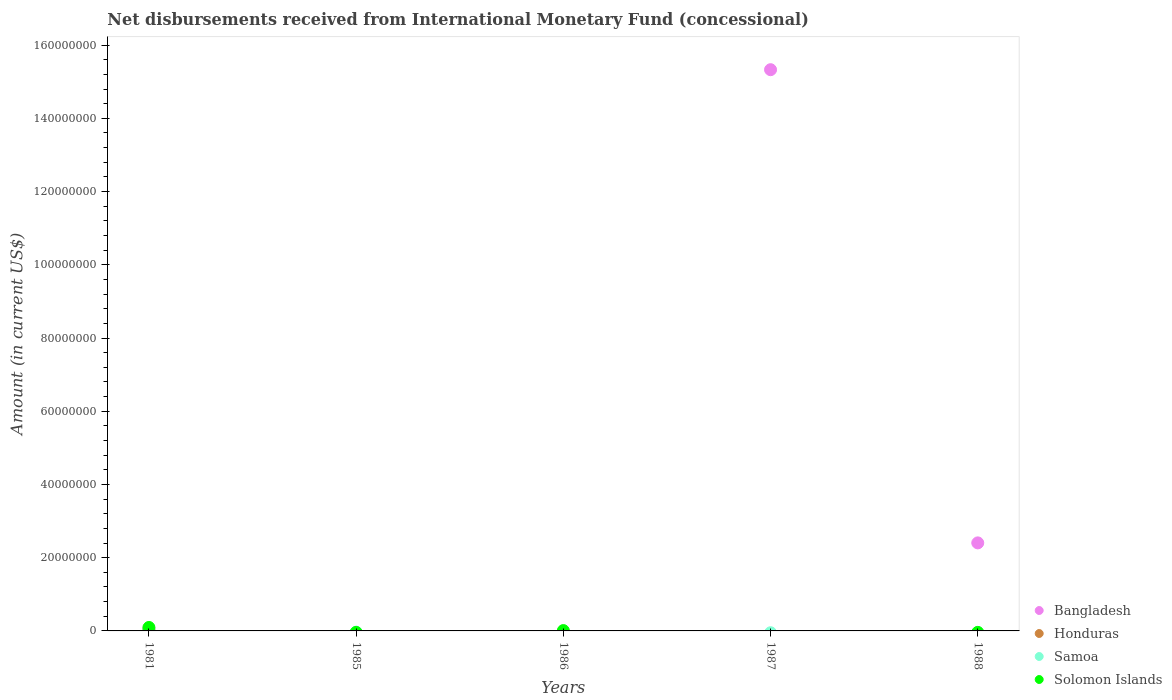Across all years, what is the maximum amount of disbursements received from International Monetary Fund in Solomon Islands?
Provide a succinct answer. 9.44e+05. Across all years, what is the minimum amount of disbursements received from International Monetary Fund in Samoa?
Ensure brevity in your answer.  0. In which year was the amount of disbursements received from International Monetary Fund in Honduras maximum?
Provide a succinct answer. 1981. What is the total amount of disbursements received from International Monetary Fund in Honduras in the graph?
Offer a terse response. 1.11e+05. What is the average amount of disbursements received from International Monetary Fund in Samoa per year?
Your answer should be compact. 1800. In the year 1981, what is the difference between the amount of disbursements received from International Monetary Fund in Solomon Islands and amount of disbursements received from International Monetary Fund in Bangladesh?
Make the answer very short. 3.50e+05. What is the ratio of the amount of disbursements received from International Monetary Fund in Bangladesh in 1987 to that in 1988?
Ensure brevity in your answer.  6.38. What is the difference between the highest and the second highest amount of disbursements received from International Monetary Fund in Bangladesh?
Offer a terse response. 1.29e+08. What is the difference between the highest and the lowest amount of disbursements received from International Monetary Fund in Honduras?
Your answer should be compact. 1.11e+05. Is the amount of disbursements received from International Monetary Fund in Bangladesh strictly greater than the amount of disbursements received from International Monetary Fund in Honduras over the years?
Offer a terse response. No. How many years are there in the graph?
Provide a succinct answer. 5. What is the difference between two consecutive major ticks on the Y-axis?
Make the answer very short. 2.00e+07. Are the values on the major ticks of Y-axis written in scientific E-notation?
Your answer should be very brief. No. Does the graph contain any zero values?
Offer a very short reply. Yes. Does the graph contain grids?
Provide a short and direct response. No. Where does the legend appear in the graph?
Your response must be concise. Bottom right. How many legend labels are there?
Offer a very short reply. 4. How are the legend labels stacked?
Offer a terse response. Vertical. What is the title of the graph?
Offer a very short reply. Net disbursements received from International Monetary Fund (concessional). What is the label or title of the Y-axis?
Your answer should be very brief. Amount (in current US$). What is the Amount (in current US$) of Bangladesh in 1981?
Your answer should be very brief. 5.94e+05. What is the Amount (in current US$) in Honduras in 1981?
Ensure brevity in your answer.  1.11e+05. What is the Amount (in current US$) of Samoa in 1981?
Ensure brevity in your answer.  9000. What is the Amount (in current US$) in Solomon Islands in 1981?
Give a very brief answer. 9.44e+05. What is the Amount (in current US$) of Solomon Islands in 1985?
Make the answer very short. 0. What is the Amount (in current US$) in Bangladesh in 1986?
Provide a short and direct response. 0. What is the Amount (in current US$) of Honduras in 1986?
Offer a very short reply. 0. What is the Amount (in current US$) of Solomon Islands in 1986?
Offer a terse response. 9.10e+04. What is the Amount (in current US$) in Bangladesh in 1987?
Your answer should be compact. 1.53e+08. What is the Amount (in current US$) in Honduras in 1987?
Offer a terse response. 0. What is the Amount (in current US$) in Solomon Islands in 1987?
Give a very brief answer. 0. What is the Amount (in current US$) of Bangladesh in 1988?
Give a very brief answer. 2.40e+07. What is the Amount (in current US$) of Honduras in 1988?
Your response must be concise. 0. What is the Amount (in current US$) of Samoa in 1988?
Make the answer very short. 0. Across all years, what is the maximum Amount (in current US$) in Bangladesh?
Your answer should be very brief. 1.53e+08. Across all years, what is the maximum Amount (in current US$) in Honduras?
Offer a very short reply. 1.11e+05. Across all years, what is the maximum Amount (in current US$) of Samoa?
Your answer should be very brief. 9000. Across all years, what is the maximum Amount (in current US$) in Solomon Islands?
Your answer should be very brief. 9.44e+05. Across all years, what is the minimum Amount (in current US$) of Honduras?
Make the answer very short. 0. What is the total Amount (in current US$) in Bangladesh in the graph?
Your response must be concise. 1.78e+08. What is the total Amount (in current US$) in Honduras in the graph?
Your response must be concise. 1.11e+05. What is the total Amount (in current US$) in Samoa in the graph?
Give a very brief answer. 9000. What is the total Amount (in current US$) in Solomon Islands in the graph?
Give a very brief answer. 1.04e+06. What is the difference between the Amount (in current US$) in Solomon Islands in 1981 and that in 1986?
Provide a succinct answer. 8.53e+05. What is the difference between the Amount (in current US$) of Bangladesh in 1981 and that in 1987?
Ensure brevity in your answer.  -1.53e+08. What is the difference between the Amount (in current US$) in Bangladesh in 1981 and that in 1988?
Give a very brief answer. -2.35e+07. What is the difference between the Amount (in current US$) of Bangladesh in 1987 and that in 1988?
Give a very brief answer. 1.29e+08. What is the difference between the Amount (in current US$) of Bangladesh in 1981 and the Amount (in current US$) of Solomon Islands in 1986?
Your response must be concise. 5.03e+05. What is the difference between the Amount (in current US$) in Honduras in 1981 and the Amount (in current US$) in Solomon Islands in 1986?
Offer a very short reply. 2.00e+04. What is the difference between the Amount (in current US$) in Samoa in 1981 and the Amount (in current US$) in Solomon Islands in 1986?
Give a very brief answer. -8.20e+04. What is the average Amount (in current US$) in Bangladesh per year?
Ensure brevity in your answer.  3.56e+07. What is the average Amount (in current US$) of Honduras per year?
Make the answer very short. 2.22e+04. What is the average Amount (in current US$) in Samoa per year?
Provide a short and direct response. 1800. What is the average Amount (in current US$) of Solomon Islands per year?
Ensure brevity in your answer.  2.07e+05. In the year 1981, what is the difference between the Amount (in current US$) in Bangladesh and Amount (in current US$) in Honduras?
Give a very brief answer. 4.83e+05. In the year 1981, what is the difference between the Amount (in current US$) of Bangladesh and Amount (in current US$) of Samoa?
Offer a terse response. 5.85e+05. In the year 1981, what is the difference between the Amount (in current US$) of Bangladesh and Amount (in current US$) of Solomon Islands?
Your answer should be compact. -3.50e+05. In the year 1981, what is the difference between the Amount (in current US$) of Honduras and Amount (in current US$) of Samoa?
Provide a short and direct response. 1.02e+05. In the year 1981, what is the difference between the Amount (in current US$) in Honduras and Amount (in current US$) in Solomon Islands?
Ensure brevity in your answer.  -8.33e+05. In the year 1981, what is the difference between the Amount (in current US$) in Samoa and Amount (in current US$) in Solomon Islands?
Your response must be concise. -9.35e+05. What is the ratio of the Amount (in current US$) of Solomon Islands in 1981 to that in 1986?
Your answer should be very brief. 10.37. What is the ratio of the Amount (in current US$) of Bangladesh in 1981 to that in 1987?
Ensure brevity in your answer.  0. What is the ratio of the Amount (in current US$) of Bangladesh in 1981 to that in 1988?
Your response must be concise. 0.02. What is the ratio of the Amount (in current US$) of Bangladesh in 1987 to that in 1988?
Offer a very short reply. 6.38. What is the difference between the highest and the second highest Amount (in current US$) in Bangladesh?
Offer a very short reply. 1.29e+08. What is the difference between the highest and the lowest Amount (in current US$) in Bangladesh?
Your response must be concise. 1.53e+08. What is the difference between the highest and the lowest Amount (in current US$) of Honduras?
Provide a short and direct response. 1.11e+05. What is the difference between the highest and the lowest Amount (in current US$) in Samoa?
Offer a very short reply. 9000. What is the difference between the highest and the lowest Amount (in current US$) in Solomon Islands?
Provide a succinct answer. 9.44e+05. 